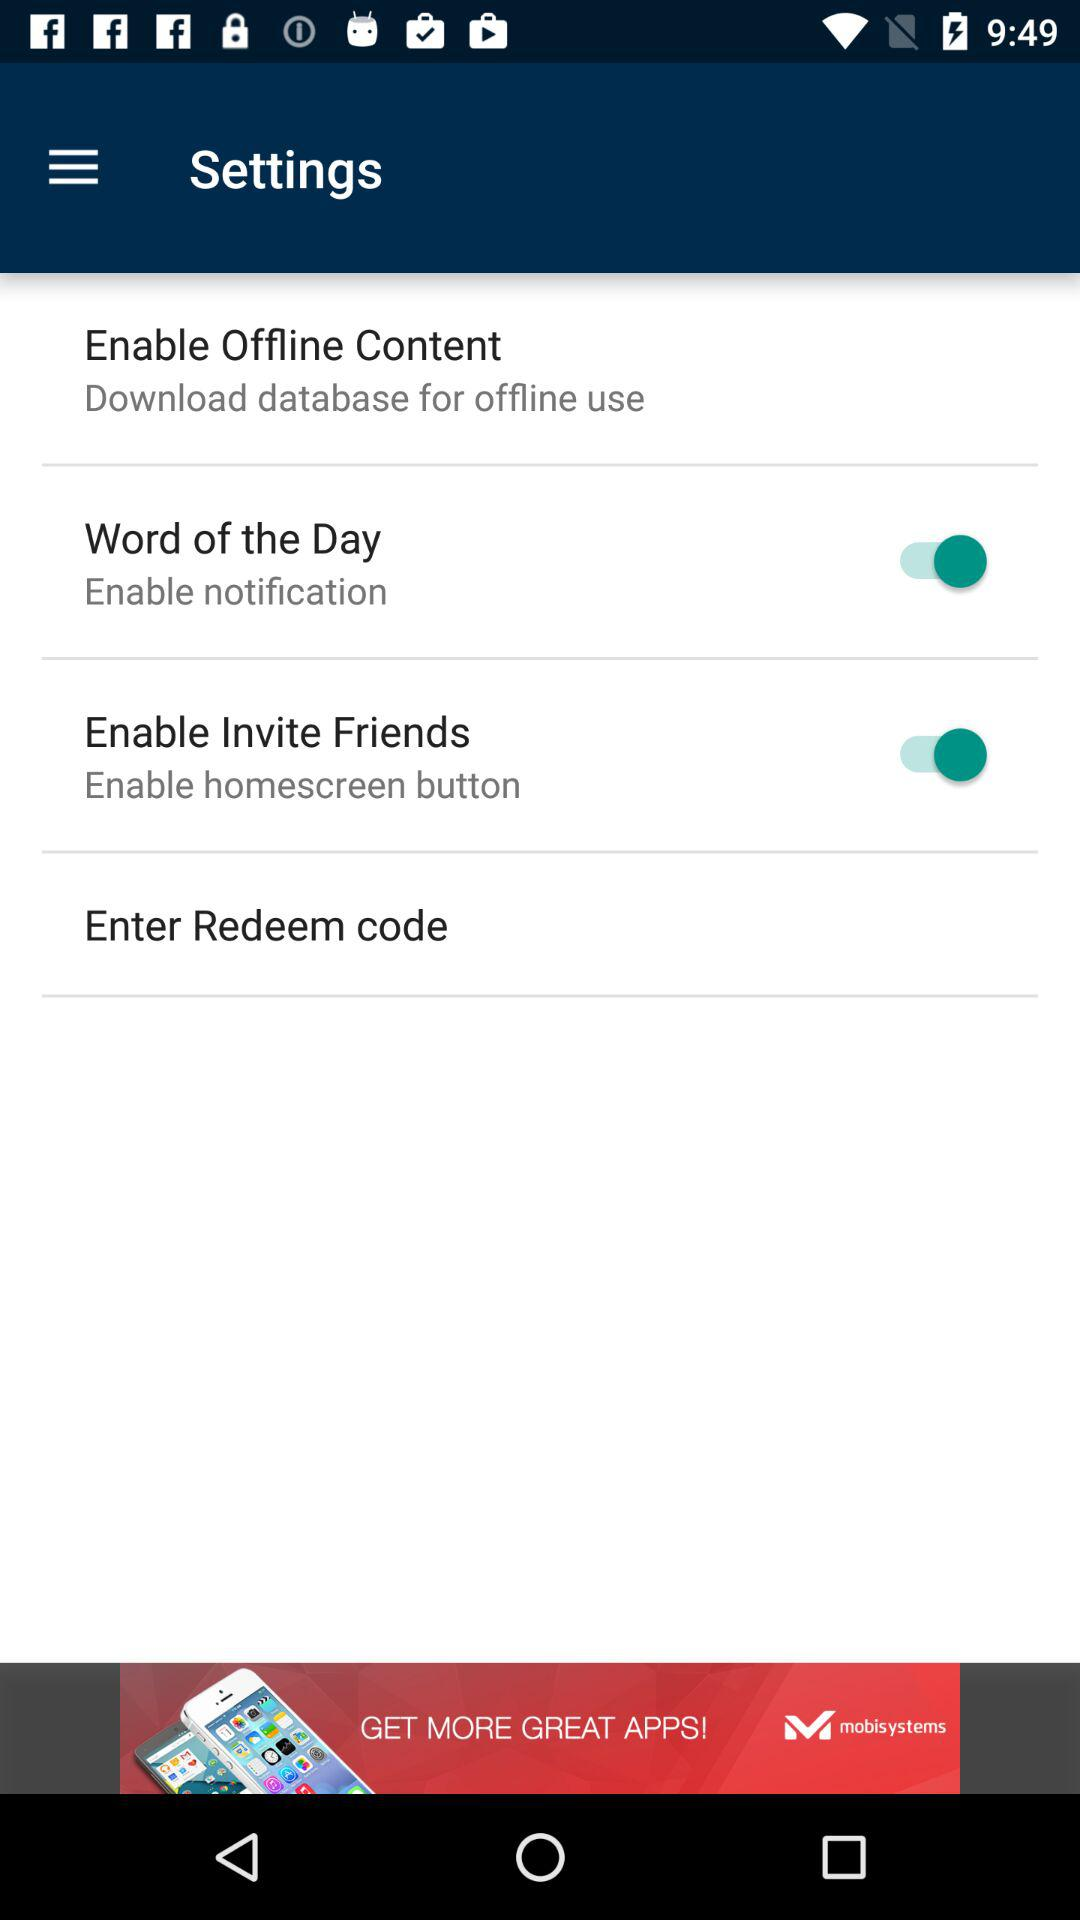What is the current status of "Enable Invite Friends"? The current status is "on". 